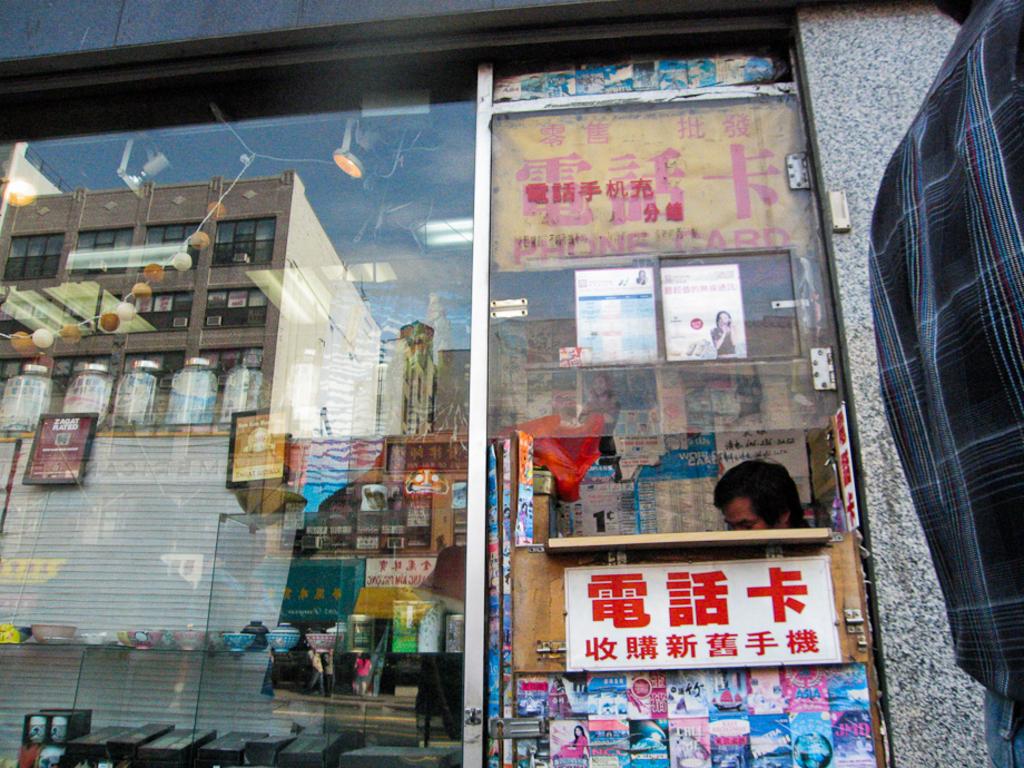What does the yellow sign say?
Provide a succinct answer. Phone card. Are the red letters on the sign under the man chinese words?
Ensure brevity in your answer.  Yes. 